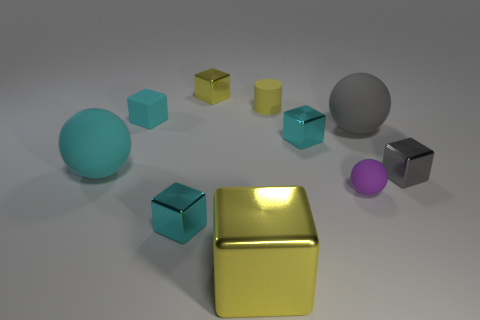What shape is the tiny purple thing that is made of the same material as the cylinder?
Offer a very short reply. Sphere. The yellow block in front of the cyan rubber thing behind the small cyan shiny block that is to the right of the large metal block is made of what material?
Ensure brevity in your answer.  Metal. There is a gray cube; is its size the same as the cyan matte thing on the left side of the tiny cyan matte object?
Your answer should be compact. No. What material is the other large thing that is the same shape as the gray metal thing?
Ensure brevity in your answer.  Metal. How big is the cyan metallic block that is behind the large cyan matte ball to the left of the yellow metallic object in front of the gray matte ball?
Make the answer very short. Small. Does the purple matte thing have the same size as the gray rubber thing?
Provide a succinct answer. No. The tiny sphere behind the yellow cube in front of the rubber cube is made of what material?
Your response must be concise. Rubber. Does the large thing that is left of the small cyan rubber block have the same shape as the large object behind the big cyan rubber thing?
Offer a very short reply. Yes. Is the number of metal things behind the tiny gray metallic thing the same as the number of tiny purple objects?
Make the answer very short. No. Is there a tiny cyan rubber object behind the small gray object that is behind the tiny purple thing?
Make the answer very short. Yes. 